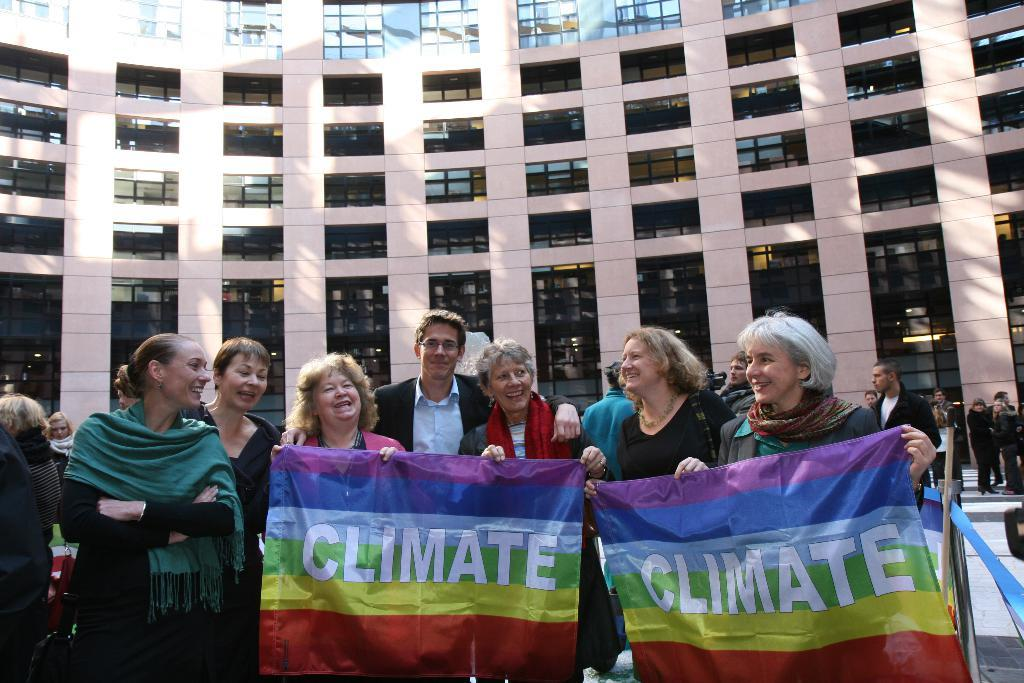What is happening in the image? There are people standing in the image. What are some of the people holding? Some of the people are holding a banner. What can be seen in the background of the image? There is a building in the background of the image. What grade does the person wearing the mask receive on their report card in the image? There is no person wearing a mask or any mention of a report card in the image. 